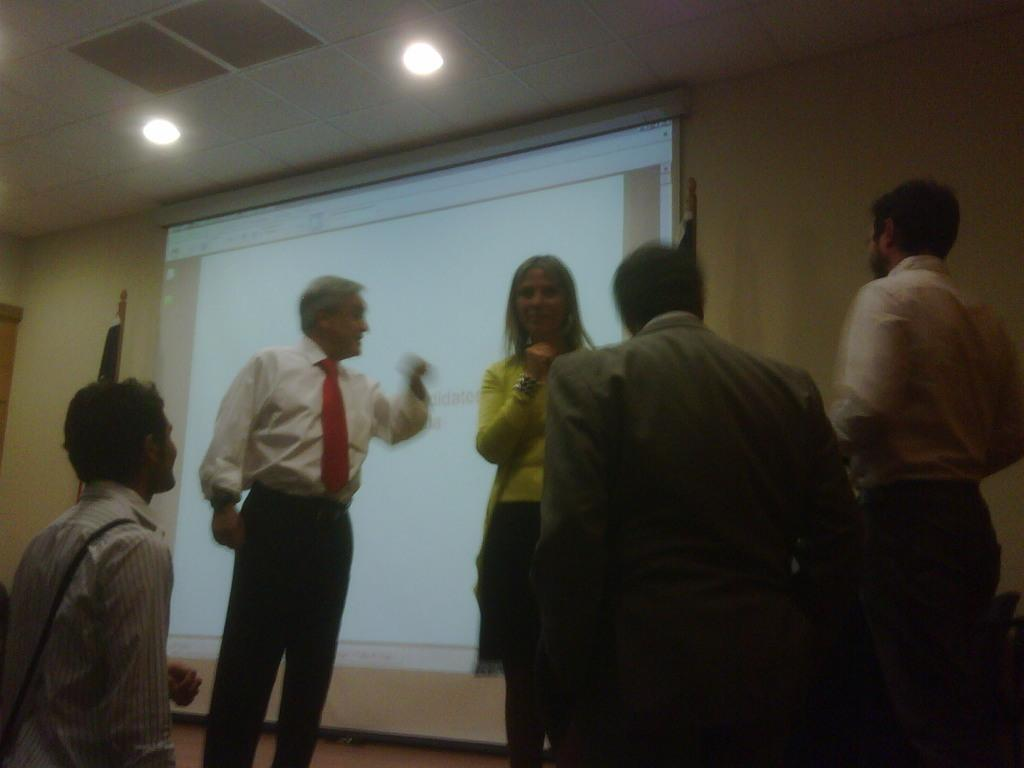Who is present in the image? There is a woman and four men in the image. What are the people in the image doing? The people are standing. What can be seen in the background of the image? There is a big screen and a wall in the background of the image. What is visible at the top of the image? The roof is visible at the top of the image, along with lights. What type of authority figure can be seen requesting the woman to look at the big screen in the image? There is no authority figure present in the image, nor is there any indication that the woman is being asked to look at the big screen. 